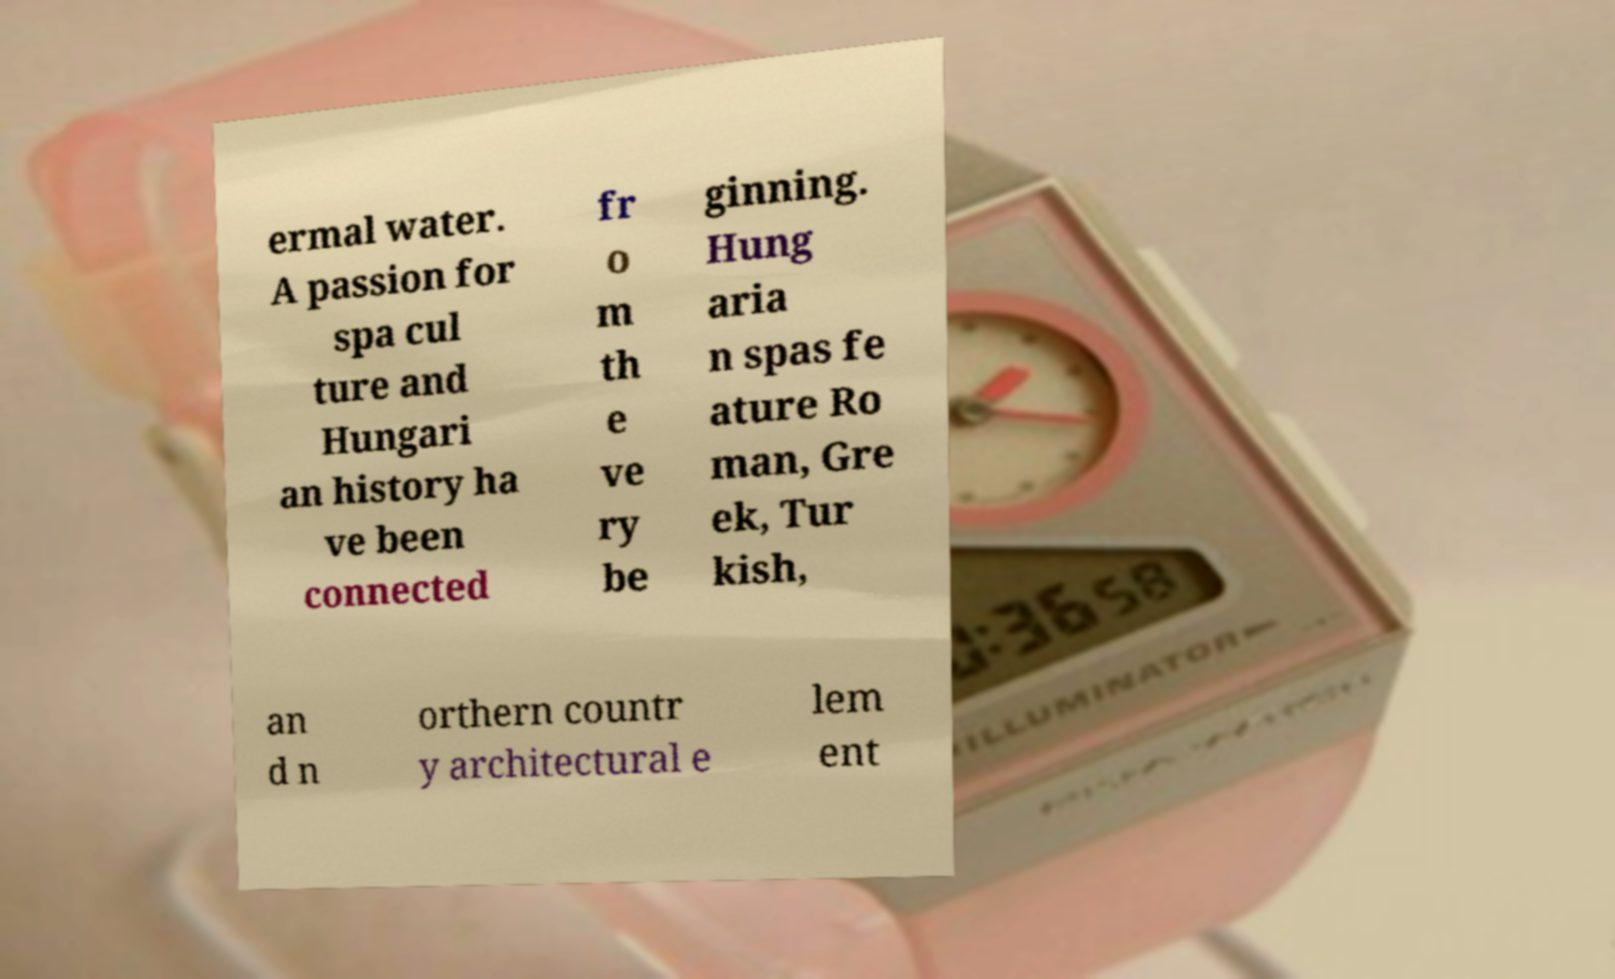Can you accurately transcribe the text from the provided image for me? ermal water. A passion for spa cul ture and Hungari an history ha ve been connected fr o m th e ve ry be ginning. Hung aria n spas fe ature Ro man, Gre ek, Tur kish, an d n orthern countr y architectural e lem ent 